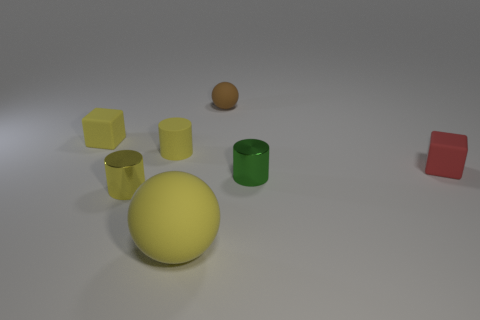Subtract all yellow cylinders. How many cylinders are left? 1 Add 3 small green metal cylinders. How many objects exist? 10 Subtract all brown balls. How many yellow cylinders are left? 2 Subtract all yellow balls. How many balls are left? 1 Subtract all cubes. How many objects are left? 5 Subtract 1 cylinders. How many cylinders are left? 2 Subtract all yellow cylinders. Subtract all gray spheres. How many cylinders are left? 1 Subtract all large spheres. Subtract all large spheres. How many objects are left? 5 Add 3 tiny yellow matte cubes. How many tiny yellow matte cubes are left? 4 Add 3 tiny matte cubes. How many tiny matte cubes exist? 5 